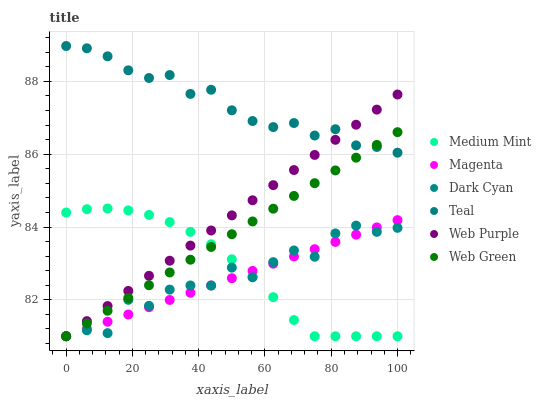Does Magenta have the minimum area under the curve?
Answer yes or no. Yes. Does Teal have the maximum area under the curve?
Answer yes or no. Yes. Does Web Green have the minimum area under the curve?
Answer yes or no. No. Does Web Green have the maximum area under the curve?
Answer yes or no. No. Is Web Green the smoothest?
Answer yes or no. Yes. Is Dark Cyan the roughest?
Answer yes or no. Yes. Is Teal the smoothest?
Answer yes or no. No. Is Teal the roughest?
Answer yes or no. No. Does Medium Mint have the lowest value?
Answer yes or no. Yes. Does Teal have the lowest value?
Answer yes or no. No. Does Teal have the highest value?
Answer yes or no. Yes. Does Web Green have the highest value?
Answer yes or no. No. Is Magenta less than Teal?
Answer yes or no. Yes. Is Teal greater than Magenta?
Answer yes or no. Yes. Does Web Purple intersect Magenta?
Answer yes or no. Yes. Is Web Purple less than Magenta?
Answer yes or no. No. Is Web Purple greater than Magenta?
Answer yes or no. No. Does Magenta intersect Teal?
Answer yes or no. No. 